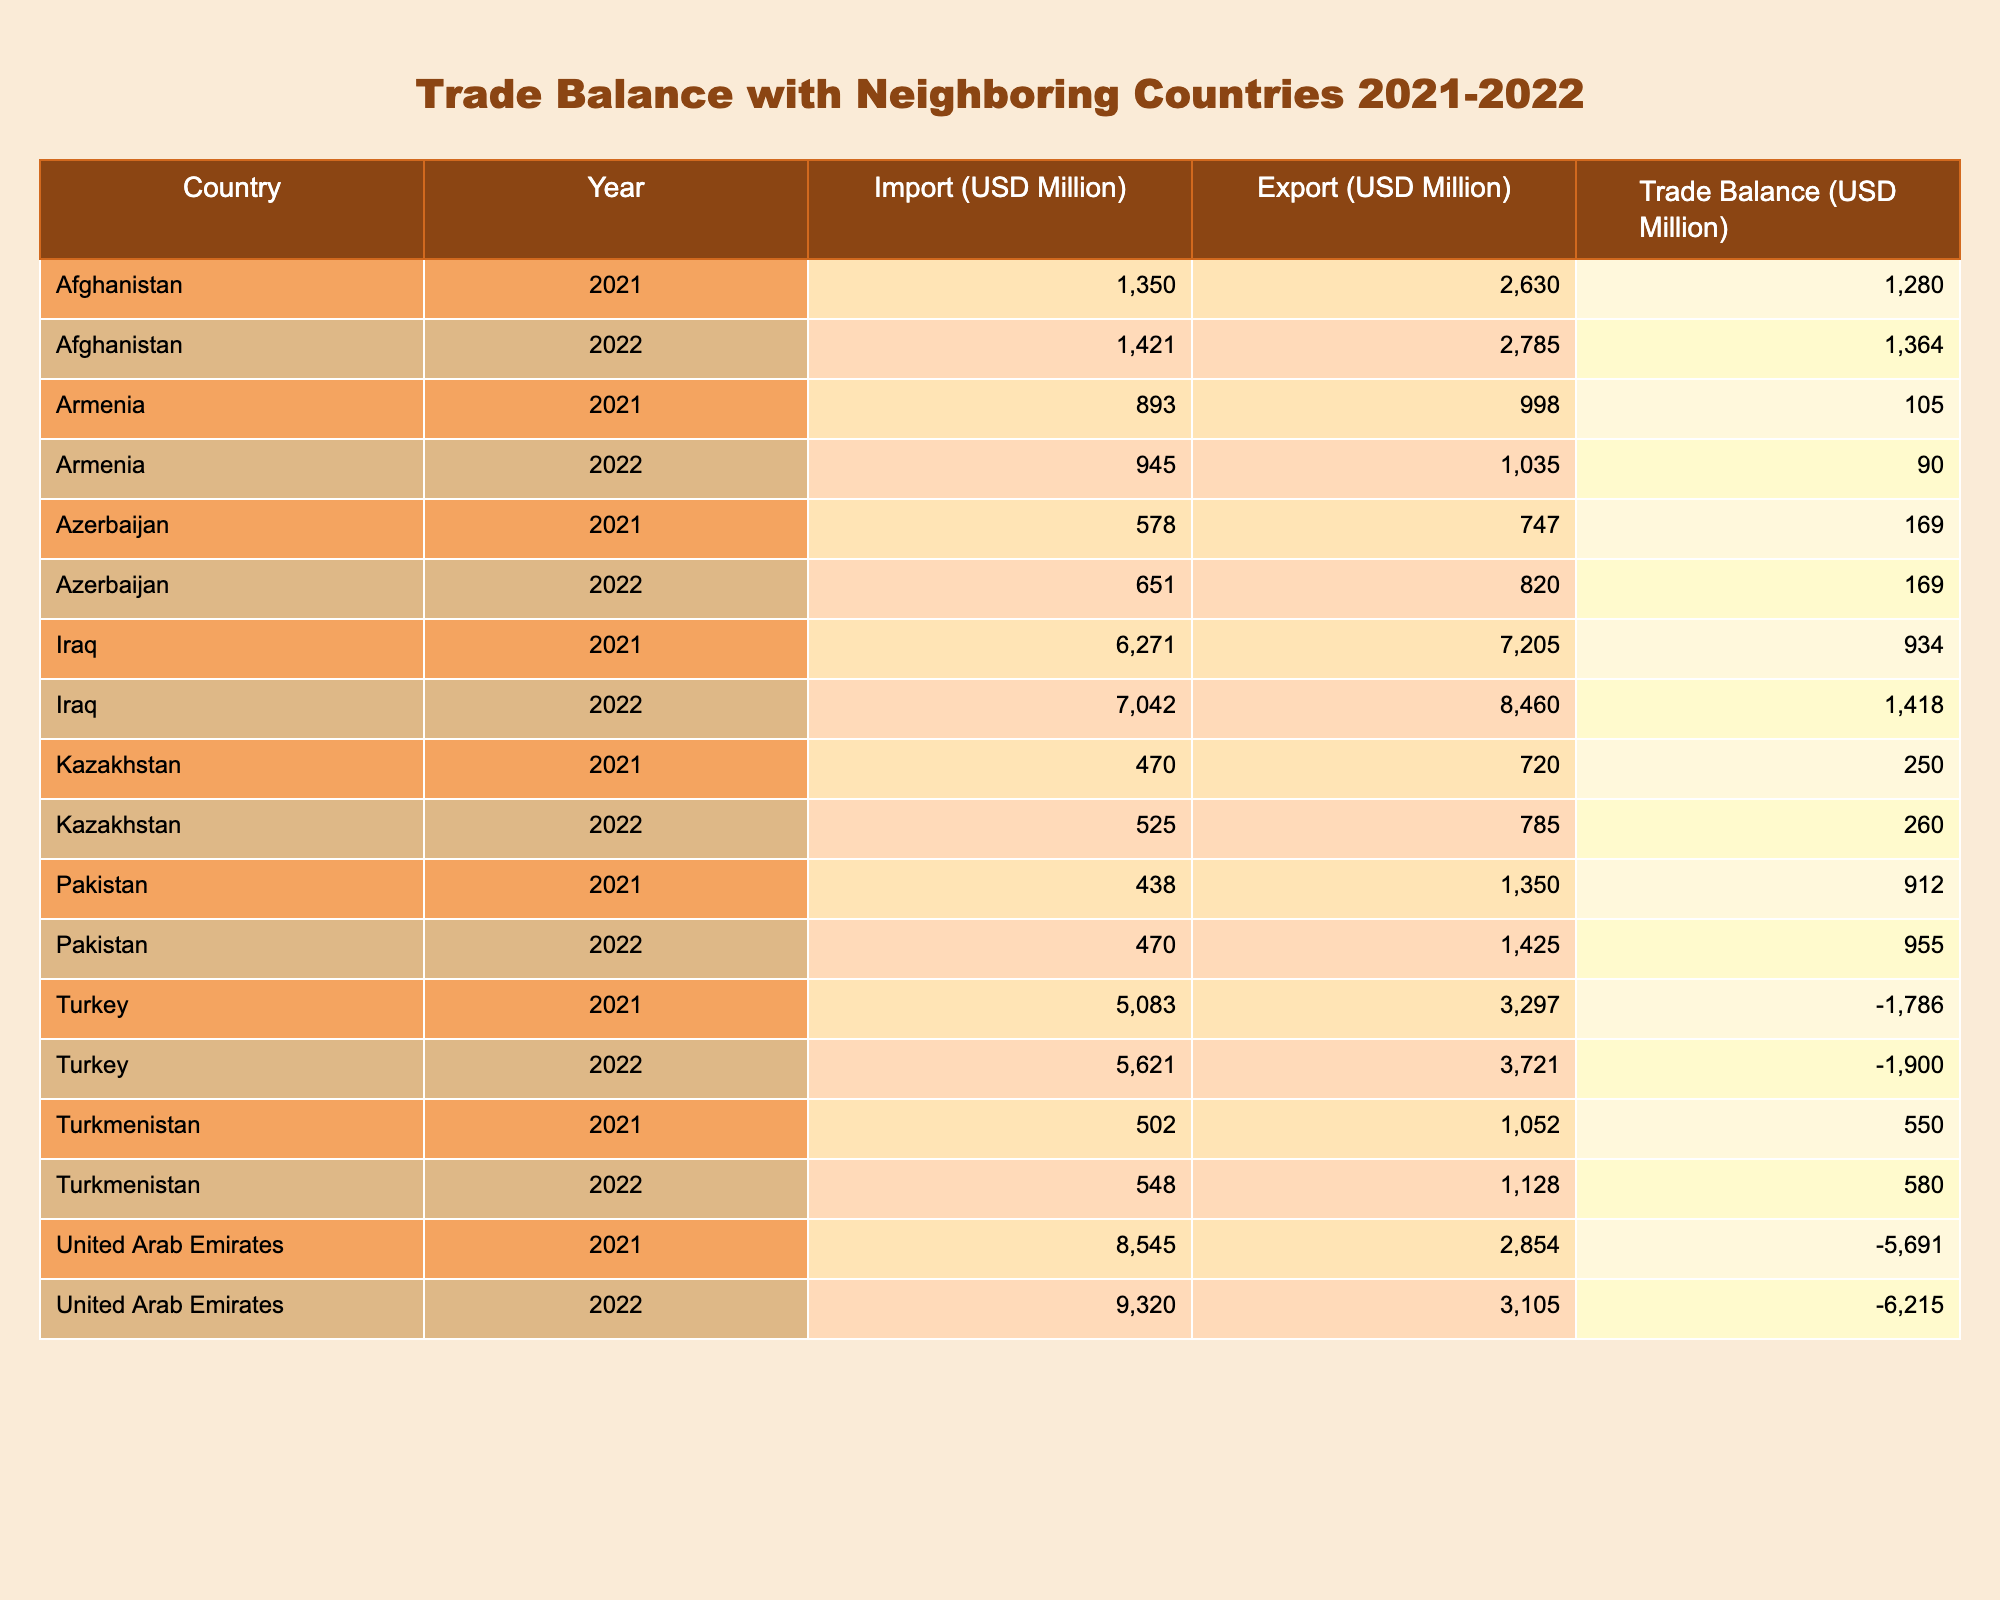What was the trade balance of Iraq in 2022? According to the table, Iraq's trade balance in 2022 is listed as 1418 million USD.
Answer: 1418 million USD In which year did Afghanistan have a higher trade balance, 2021 or 2022? Looking at the trade balances for Afghanistan, in 2021 it was 1280 million USD, while in 2022 it was 1364 million USD. Since 1364 is greater than 1280, Afghanistan had a higher trade balance in 2022.
Answer: 2022 What is the total trade balance for Turkey over the two years? Turkey's trade balances are -1786 million USD for 2021 and -1900 million USD for 2022. Summing these gives -1786 + (-1900) = -3686 million USD, indicating a trade deficit over the two years.
Answer: -3686 million USD Did Kazakhstan have a positive trade balance in both years? From the table, Kazakhstan's trade balances are 250 million USD in 2021 and 260 million USD in 2022. Both values are positive, confirming that Kazakhstan had a positive trade balance in each year.
Answer: Yes Which neighboring country had the worst trade balance in 2022? The trade balance figures for 2022 show that the United Arab Emirates had the worst trade balance at -6215 million USD. Thus, the UAE had the most significant trade deficit compared to other neighbors.
Answer: United Arab Emirates 